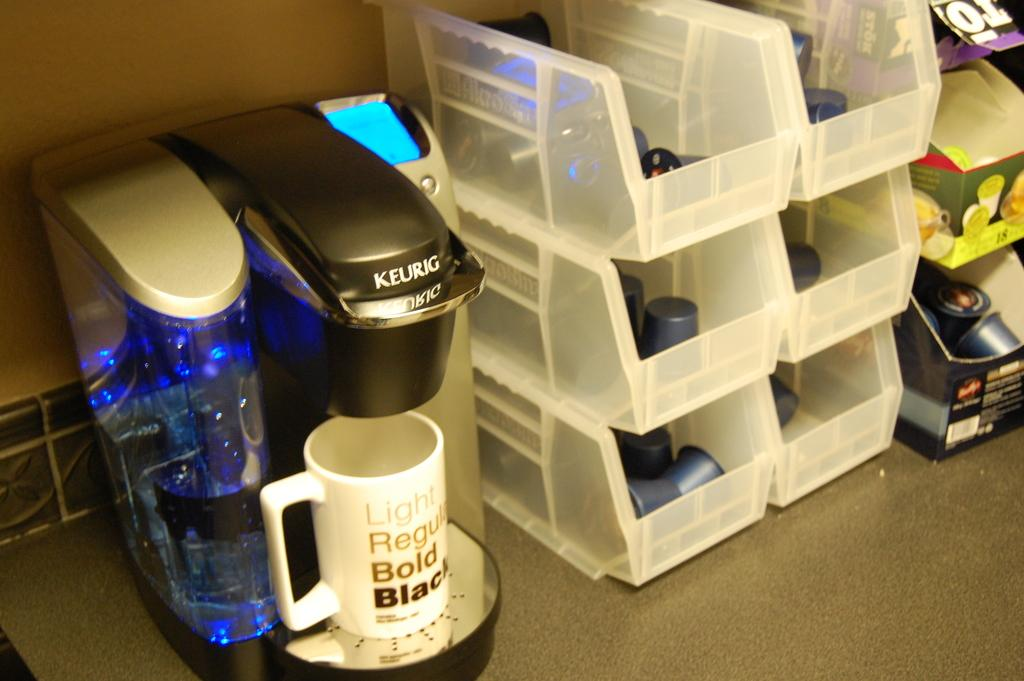<image>
Render a clear and concise summary of the photo. A Keurig with a coffee cup that says Light, Regular, Bold, Black is shown on a counter next to containers of creamer. 